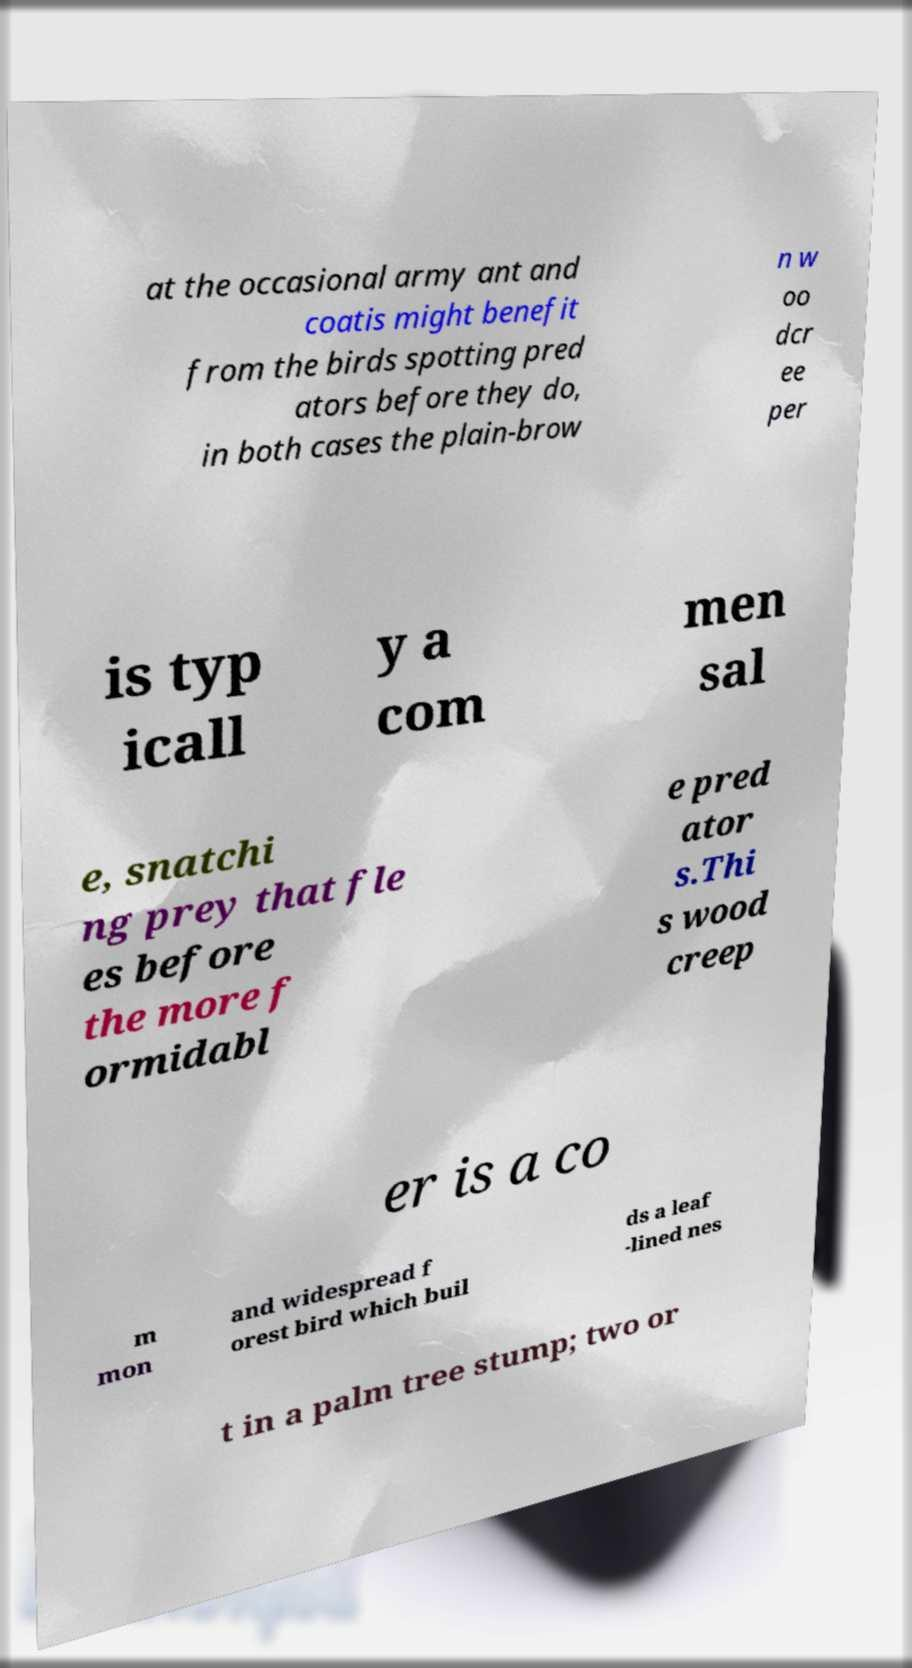Please identify and transcribe the text found in this image. at the occasional army ant and coatis might benefit from the birds spotting pred ators before they do, in both cases the plain-brow n w oo dcr ee per is typ icall y a com men sal e, snatchi ng prey that fle es before the more f ormidabl e pred ator s.Thi s wood creep er is a co m mon and widespread f orest bird which buil ds a leaf -lined nes t in a palm tree stump; two or 